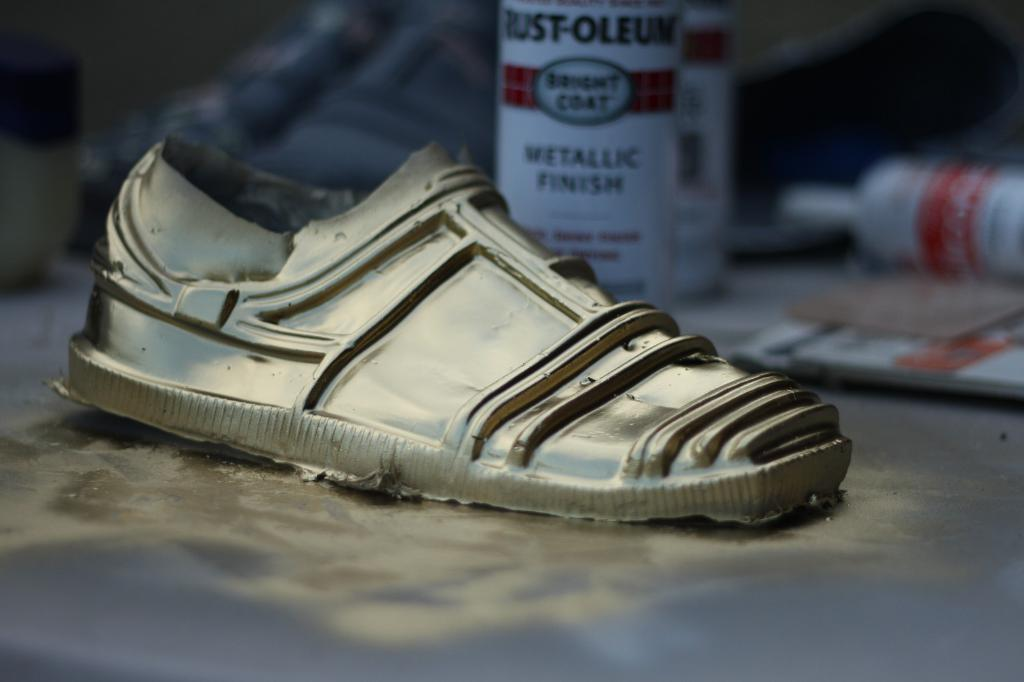What type of objects can be seen in the image? There are footwear and bottles in the image. Where are these objects located? The objects are on a platform in the image. Can you describe the background of the image? The background of the image is blurry. What type of crown is placed on top of the pie in the image? There is no crown or pie present in the image. 